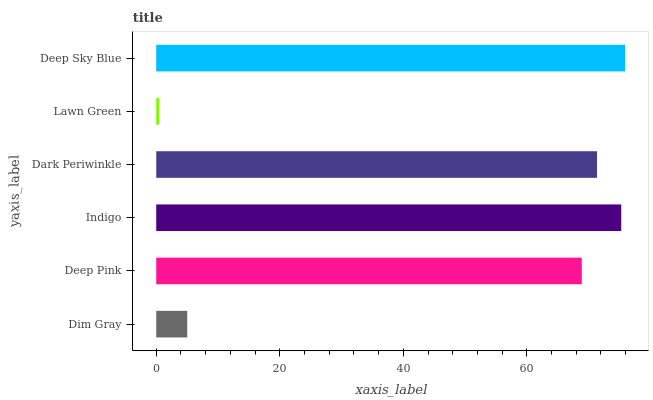Is Lawn Green the minimum?
Answer yes or no. Yes. Is Deep Sky Blue the maximum?
Answer yes or no. Yes. Is Deep Pink the minimum?
Answer yes or no. No. Is Deep Pink the maximum?
Answer yes or no. No. Is Deep Pink greater than Dim Gray?
Answer yes or no. Yes. Is Dim Gray less than Deep Pink?
Answer yes or no. Yes. Is Dim Gray greater than Deep Pink?
Answer yes or no. No. Is Deep Pink less than Dim Gray?
Answer yes or no. No. Is Dark Periwinkle the high median?
Answer yes or no. Yes. Is Deep Pink the low median?
Answer yes or no. Yes. Is Lawn Green the high median?
Answer yes or no. No. Is Deep Sky Blue the low median?
Answer yes or no. No. 